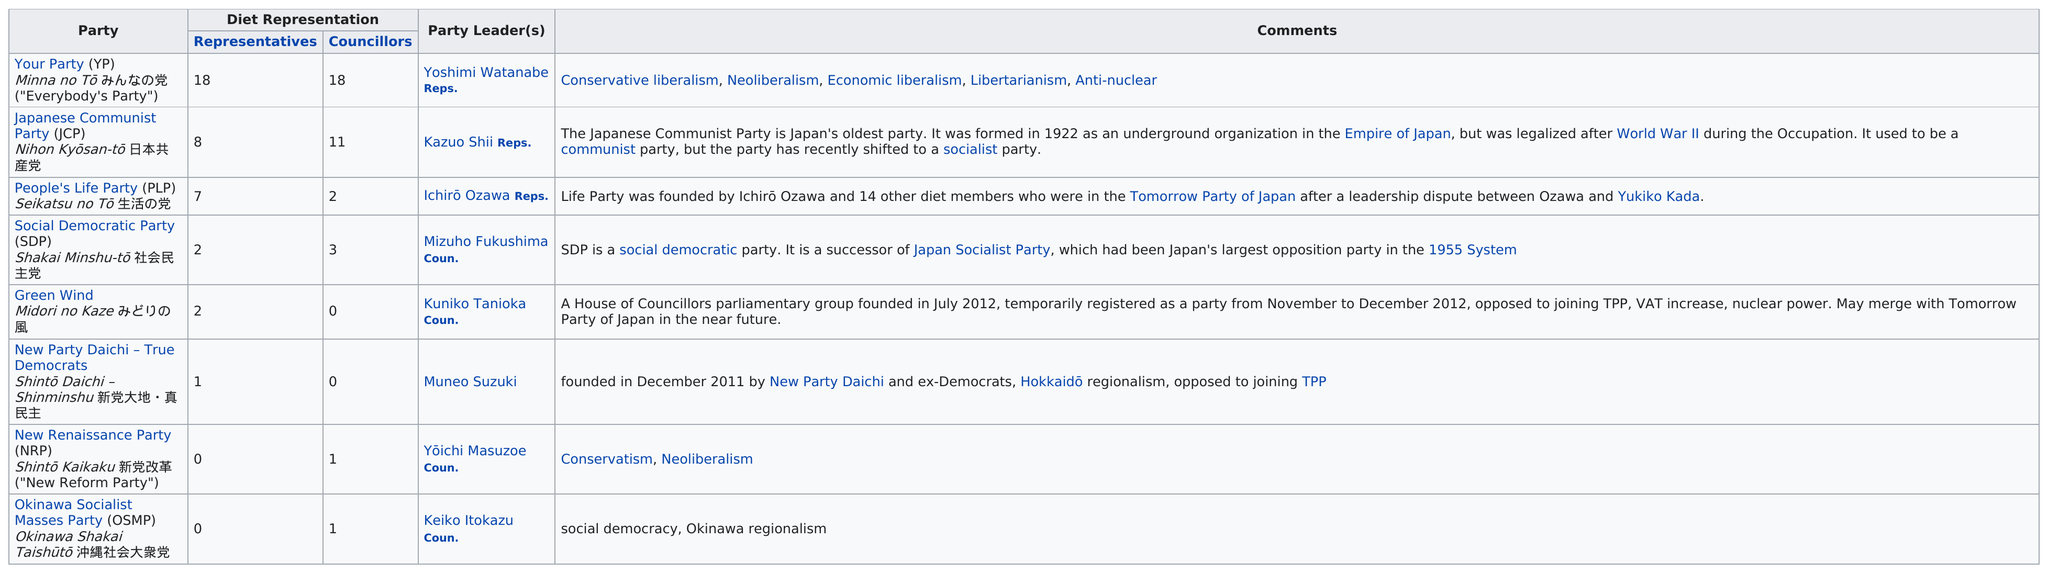Mention a couple of crucial points in this snapshot. According to the table, the Japanese Communist Party (JCP) is Japan's oldest political party, also known as the Japanese Communist Party (JCP) or Nihon Kyōsan-tō 日本共産党. The maximum number of party leaders in a people's life party is 1. Currently, two of these parties do not have any councillors. According to recent reports, the Green Wind Party currently has two representatives in the legislative body. My party has the most representatives in the Diet, which is a testament to our strong support among the Japanese people. 